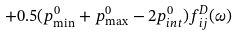Convert formula to latex. <formula><loc_0><loc_0><loc_500><loc_500>+ 0 . 5 ( p _ { \min } ^ { 0 } + p _ { \max } ^ { 0 } - 2 p _ { i n t } ^ { 0 } ) f ^ { D } _ { i j } ( \omega )</formula> 